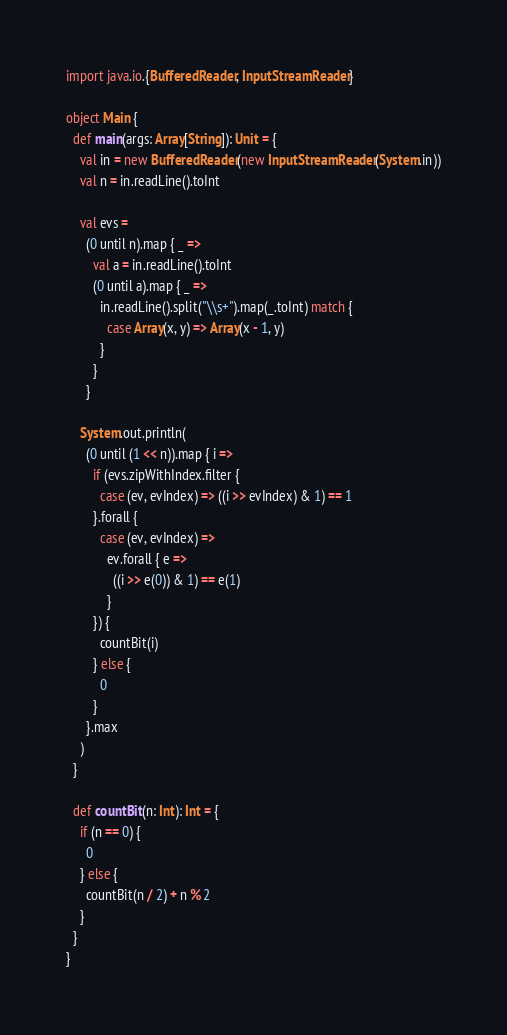<code> <loc_0><loc_0><loc_500><loc_500><_Scala_>import java.io.{BufferedReader, InputStreamReader}

object Main {
  def main(args: Array[String]): Unit = {
    val in = new BufferedReader(new InputStreamReader(System.in))
    val n = in.readLine().toInt

    val evs =
      (0 until n).map { _ =>
        val a = in.readLine().toInt
        (0 until a).map { _ =>
          in.readLine().split("\\s+").map(_.toInt) match {
            case Array(x, y) => Array(x - 1, y)
          }
        }
      }

    System.out.println(
      (0 until (1 << n)).map { i =>
        if (evs.zipWithIndex.filter {
          case (ev, evIndex) => ((i >> evIndex) & 1) == 1
        }.forall {
          case (ev, evIndex) =>
            ev.forall { e =>
              ((i >> e(0)) & 1) == e(1)
            }
        }) {
          countBit(i)
        } else {
          0
        }
      }.max
    )
  }

  def countBit(n: Int): Int = {
    if (n == 0) {
      0
    } else {
      countBit(n / 2) + n % 2
    }
  }
}
</code> 